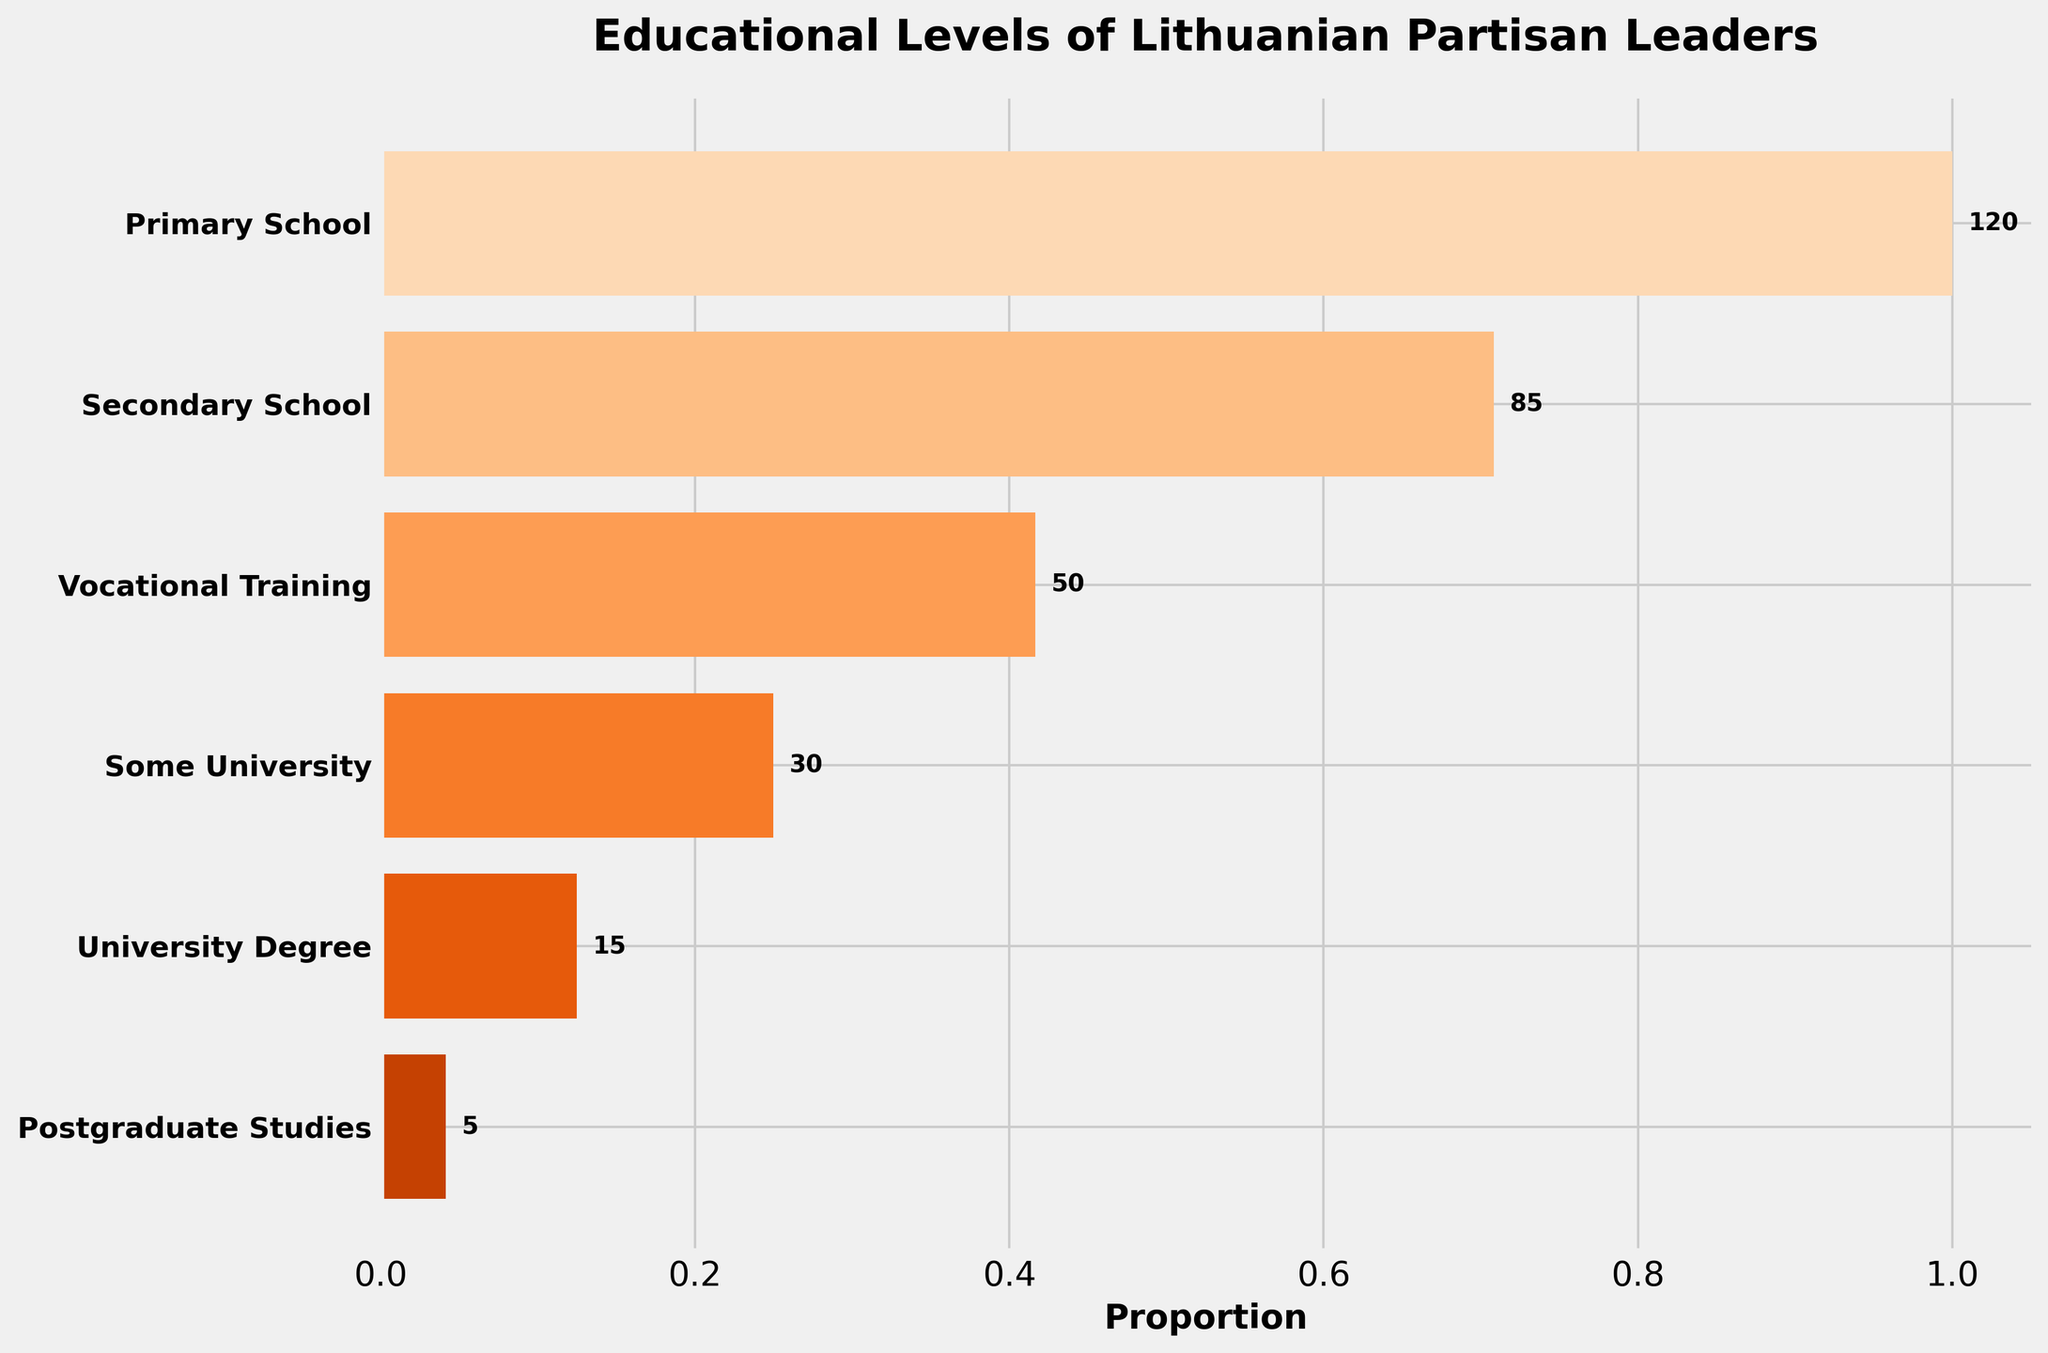what is the title of the plot? Look at the top of the figure where the title is placed, typically in bigger and bold text.
Answer: Educational Levels of Lithuanian Partisan Leaders Which educational level has the smallest number of partisan leaders? Find the shortest bar in the funnel chart which signifies the smallest number.
Answer: Postgraduate Studies How many partisan leaders have a university degree? Identify the bar labeled "University Degree" and read the number next to the bar.
Answer: 15 What is the total number of partisan leaders who completed secondary school or higher education? Sum the numbers next to the bars from "Secondary School" to the highest educational level, "Postgraduate Studies".
Answer: 85 + 50 + 30 + 15 + 5 = 185 What is the difference in the number of partisan leaders between vocational training and primary school? Subtract the number of partisan leaders with vocational training from those with primary school education.
Answer: 120 - 50 = 70 Which educational group has more partisan leaders: 'Some University' or 'Secondary School'? Compare the numbers next to the bars labeled "Some University" and "Secondary School".
Answer: Secondary School Among the top three educational groups, which one has the majority of partisan leaders? The top three bars are "Primary School", "Secondary School", and "Vocational Training". Check which has the highest number.
Answer: Primary School What proportion of partisan leaders have completed postgraduate studies compared to those with vocational training? Divide the number of postgraduate leaders by the number of vocational training leaders and express it as a proportion.
Answer: 5 / 50 = 0.1 or 10% How many educational levels are represented in the funnel chart? Count the number of different bars (educational levels) shown in the funnel chart.
Answer: 6 